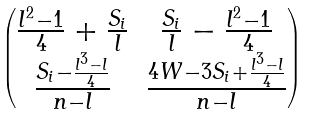Convert formula to latex. <formula><loc_0><loc_0><loc_500><loc_500>\begin{pmatrix} \frac { l ^ { 2 } - 1 } { 4 } + \frac { S _ { i } } { l } & \frac { S _ { i } } { l } - \frac { l ^ { 2 } - 1 } { 4 } \\ \frac { S _ { i } - \frac { l ^ { 3 } - l } { 4 } } { n - l } & \frac { 4 W - 3 S _ { i } + \frac { l ^ { 3 } - l } { 4 } } { n - l } \end{pmatrix}</formula> 